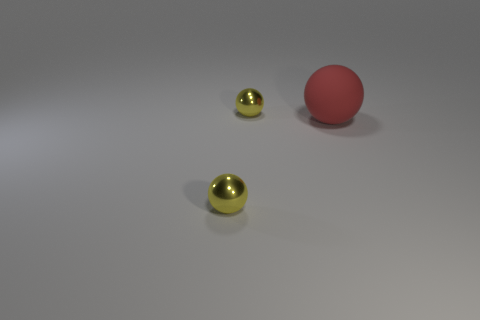Add 2 yellow spheres. How many objects exist? 5 Add 3 big red metallic spheres. How many big red metallic spheres exist? 3 Subtract 0 purple cylinders. How many objects are left? 3 Subtract all red matte objects. Subtract all large red objects. How many objects are left? 1 Add 3 shiny things. How many shiny things are left? 5 